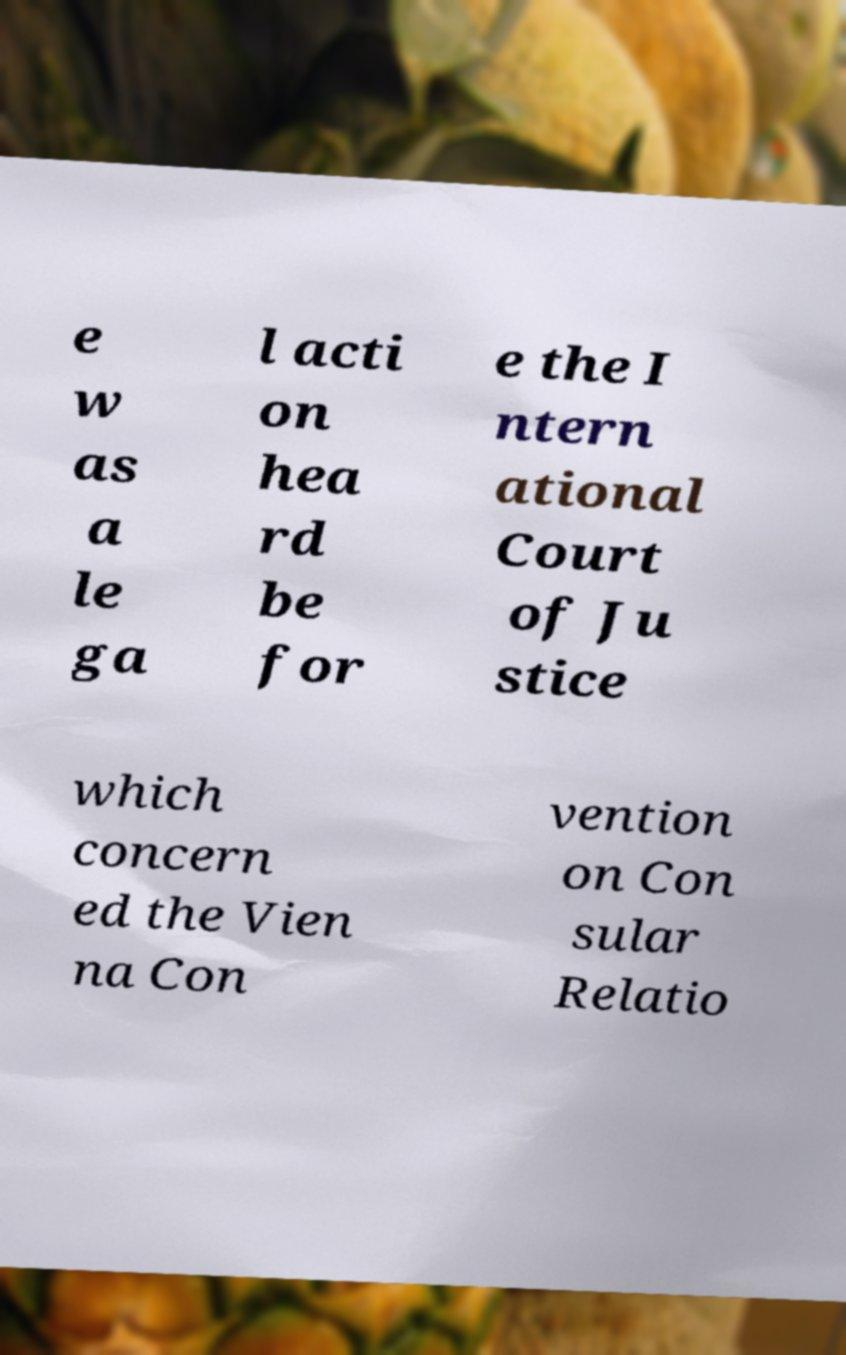Please read and relay the text visible in this image. What does it say? e w as a le ga l acti on hea rd be for e the I ntern ational Court of Ju stice which concern ed the Vien na Con vention on Con sular Relatio 